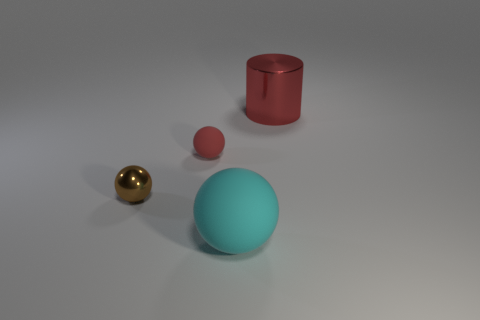There is a cyan matte object; is its size the same as the red object to the right of the tiny red matte ball?
Give a very brief answer. Yes. What is the shape of the thing that is behind the small rubber ball?
Offer a terse response. Cylinder. Is there anything else that has the same shape as the big red metallic thing?
Give a very brief answer. No. Are there any large cyan metal spheres?
Keep it short and to the point. No. Does the matte thing to the left of the large cyan sphere have the same size as the metal thing that is on the left side of the red cylinder?
Your answer should be very brief. Yes. The thing that is both behind the small brown metal thing and on the left side of the large cyan ball is made of what material?
Offer a terse response. Rubber. There is a brown metallic ball; what number of cyan things are behind it?
Provide a succinct answer. 0. What is the color of the other ball that is the same material as the large sphere?
Provide a succinct answer. Red. Is the shape of the cyan matte thing the same as the large red thing?
Your answer should be compact. No. How many objects are both behind the big matte sphere and to the right of the red rubber sphere?
Provide a short and direct response. 1. 